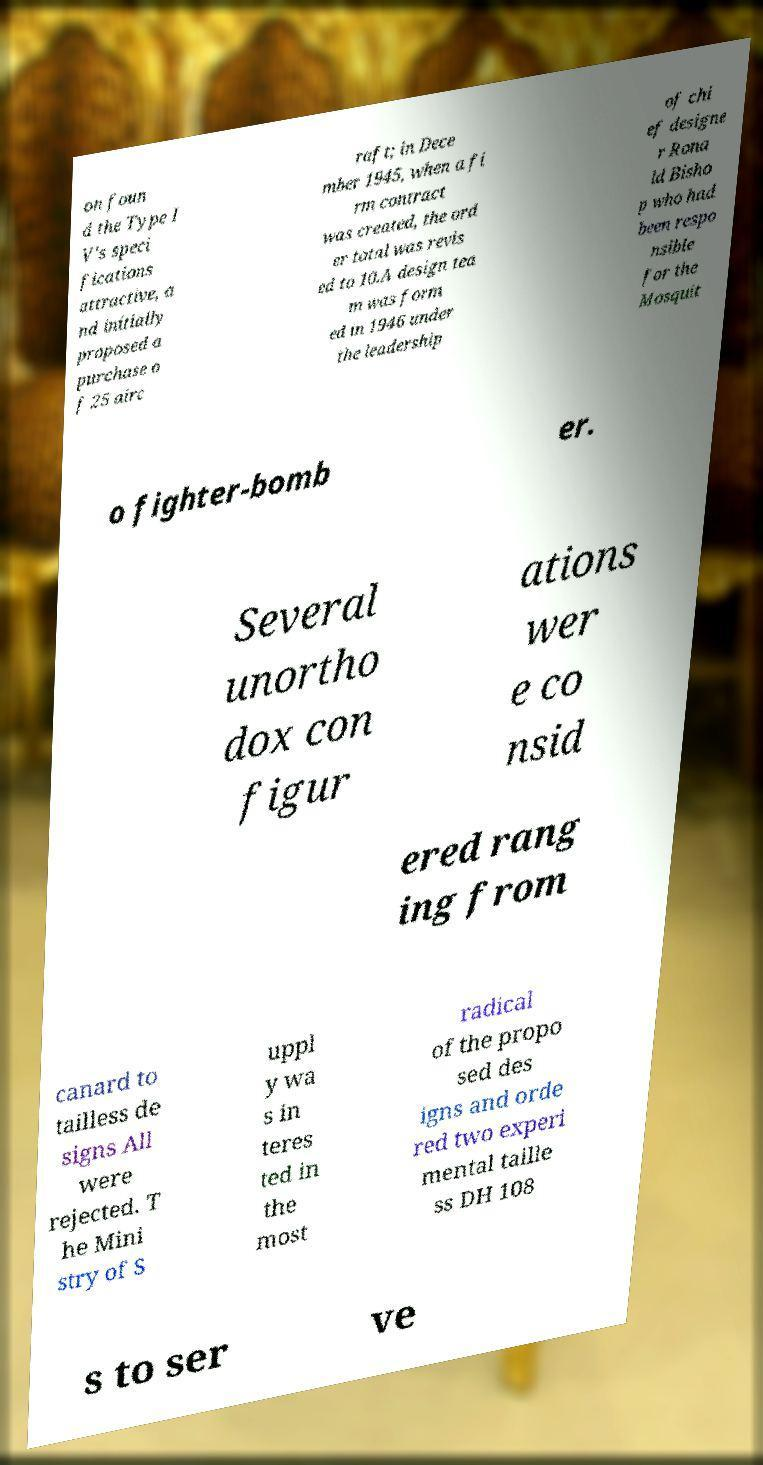Could you extract and type out the text from this image? on foun d the Type I V's speci fications attractive, a nd initially proposed a purchase o f 25 airc raft; in Dece mber 1945, when a fi rm contract was created, the ord er total was revis ed to 10.A design tea m was form ed in 1946 under the leadership of chi ef designe r Rona ld Bisho p who had been respo nsible for the Mosquit o fighter-bomb er. Several unortho dox con figur ations wer e co nsid ered rang ing from canard to tailless de signs All were rejected. T he Mini stry of S uppl y wa s in teres ted in the most radical of the propo sed des igns and orde red two experi mental taille ss DH 108 s to ser ve 